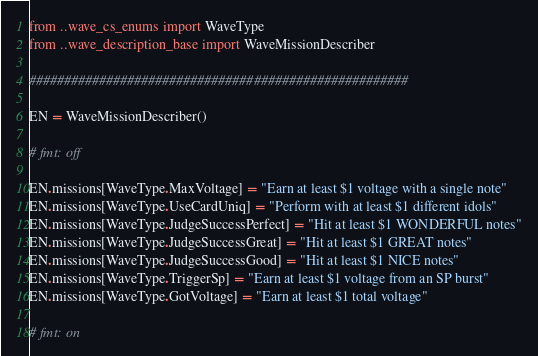Convert code to text. <code><loc_0><loc_0><loc_500><loc_500><_Python_>from ..wave_cs_enums import WaveType
from ..wave_description_base import WaveMissionDescriber

######################################################

EN = WaveMissionDescriber()

# fmt: off

EN.missions[WaveType.MaxVoltage] = "Earn at least $1 voltage with a single note"
EN.missions[WaveType.UseCardUniq] = "Perform with at least $1 different idols"
EN.missions[WaveType.JudgeSuccessPerfect] = "Hit at least $1 WONDERFUL notes"
EN.missions[WaveType.JudgeSuccessGreat] = "Hit at least $1 GREAT notes"
EN.missions[WaveType.JudgeSuccessGood] = "Hit at least $1 NICE notes"
EN.missions[WaveType.TriggerSp] = "Earn at least $1 voltage from an SP burst"
EN.missions[WaveType.GotVoltage] = "Earn at least $1 total voltage"

# fmt: on
</code> 